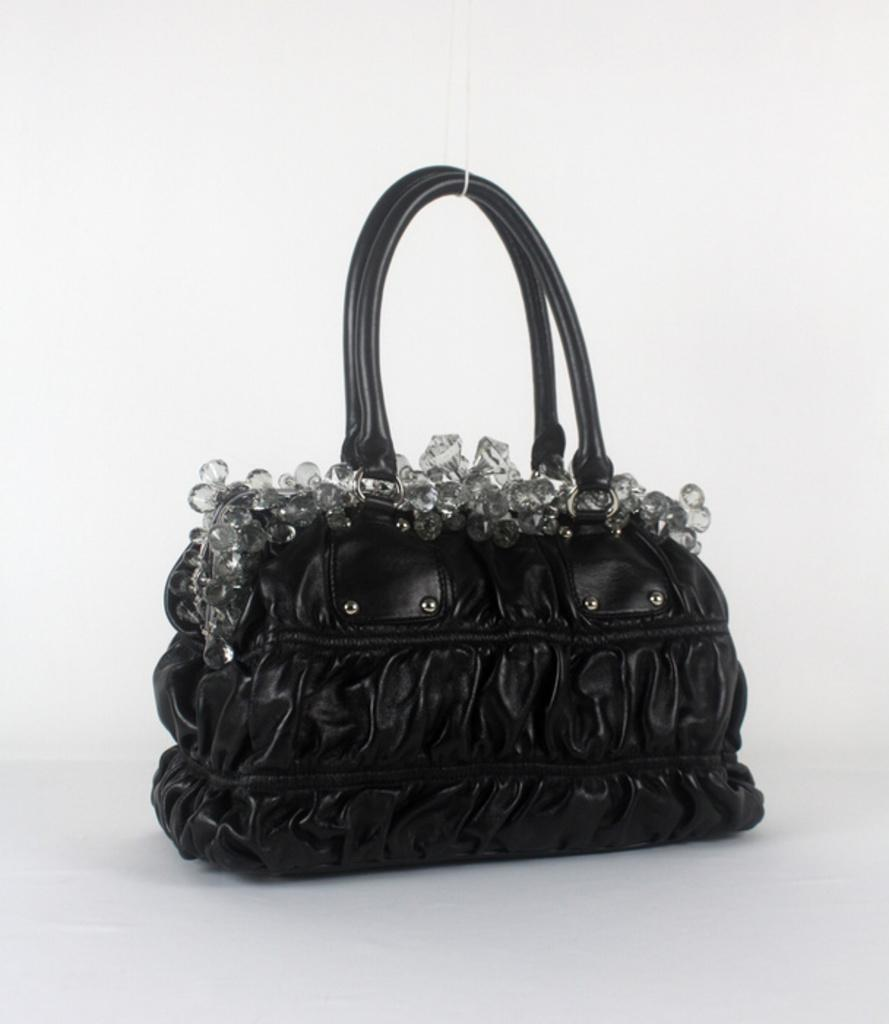What type of handbag is visible in the image? There is a black color handbag in the image. How many seeds are inside the handbag in the image? There are no seeds present in the image, as it features a handbag and not a container for seeds. 